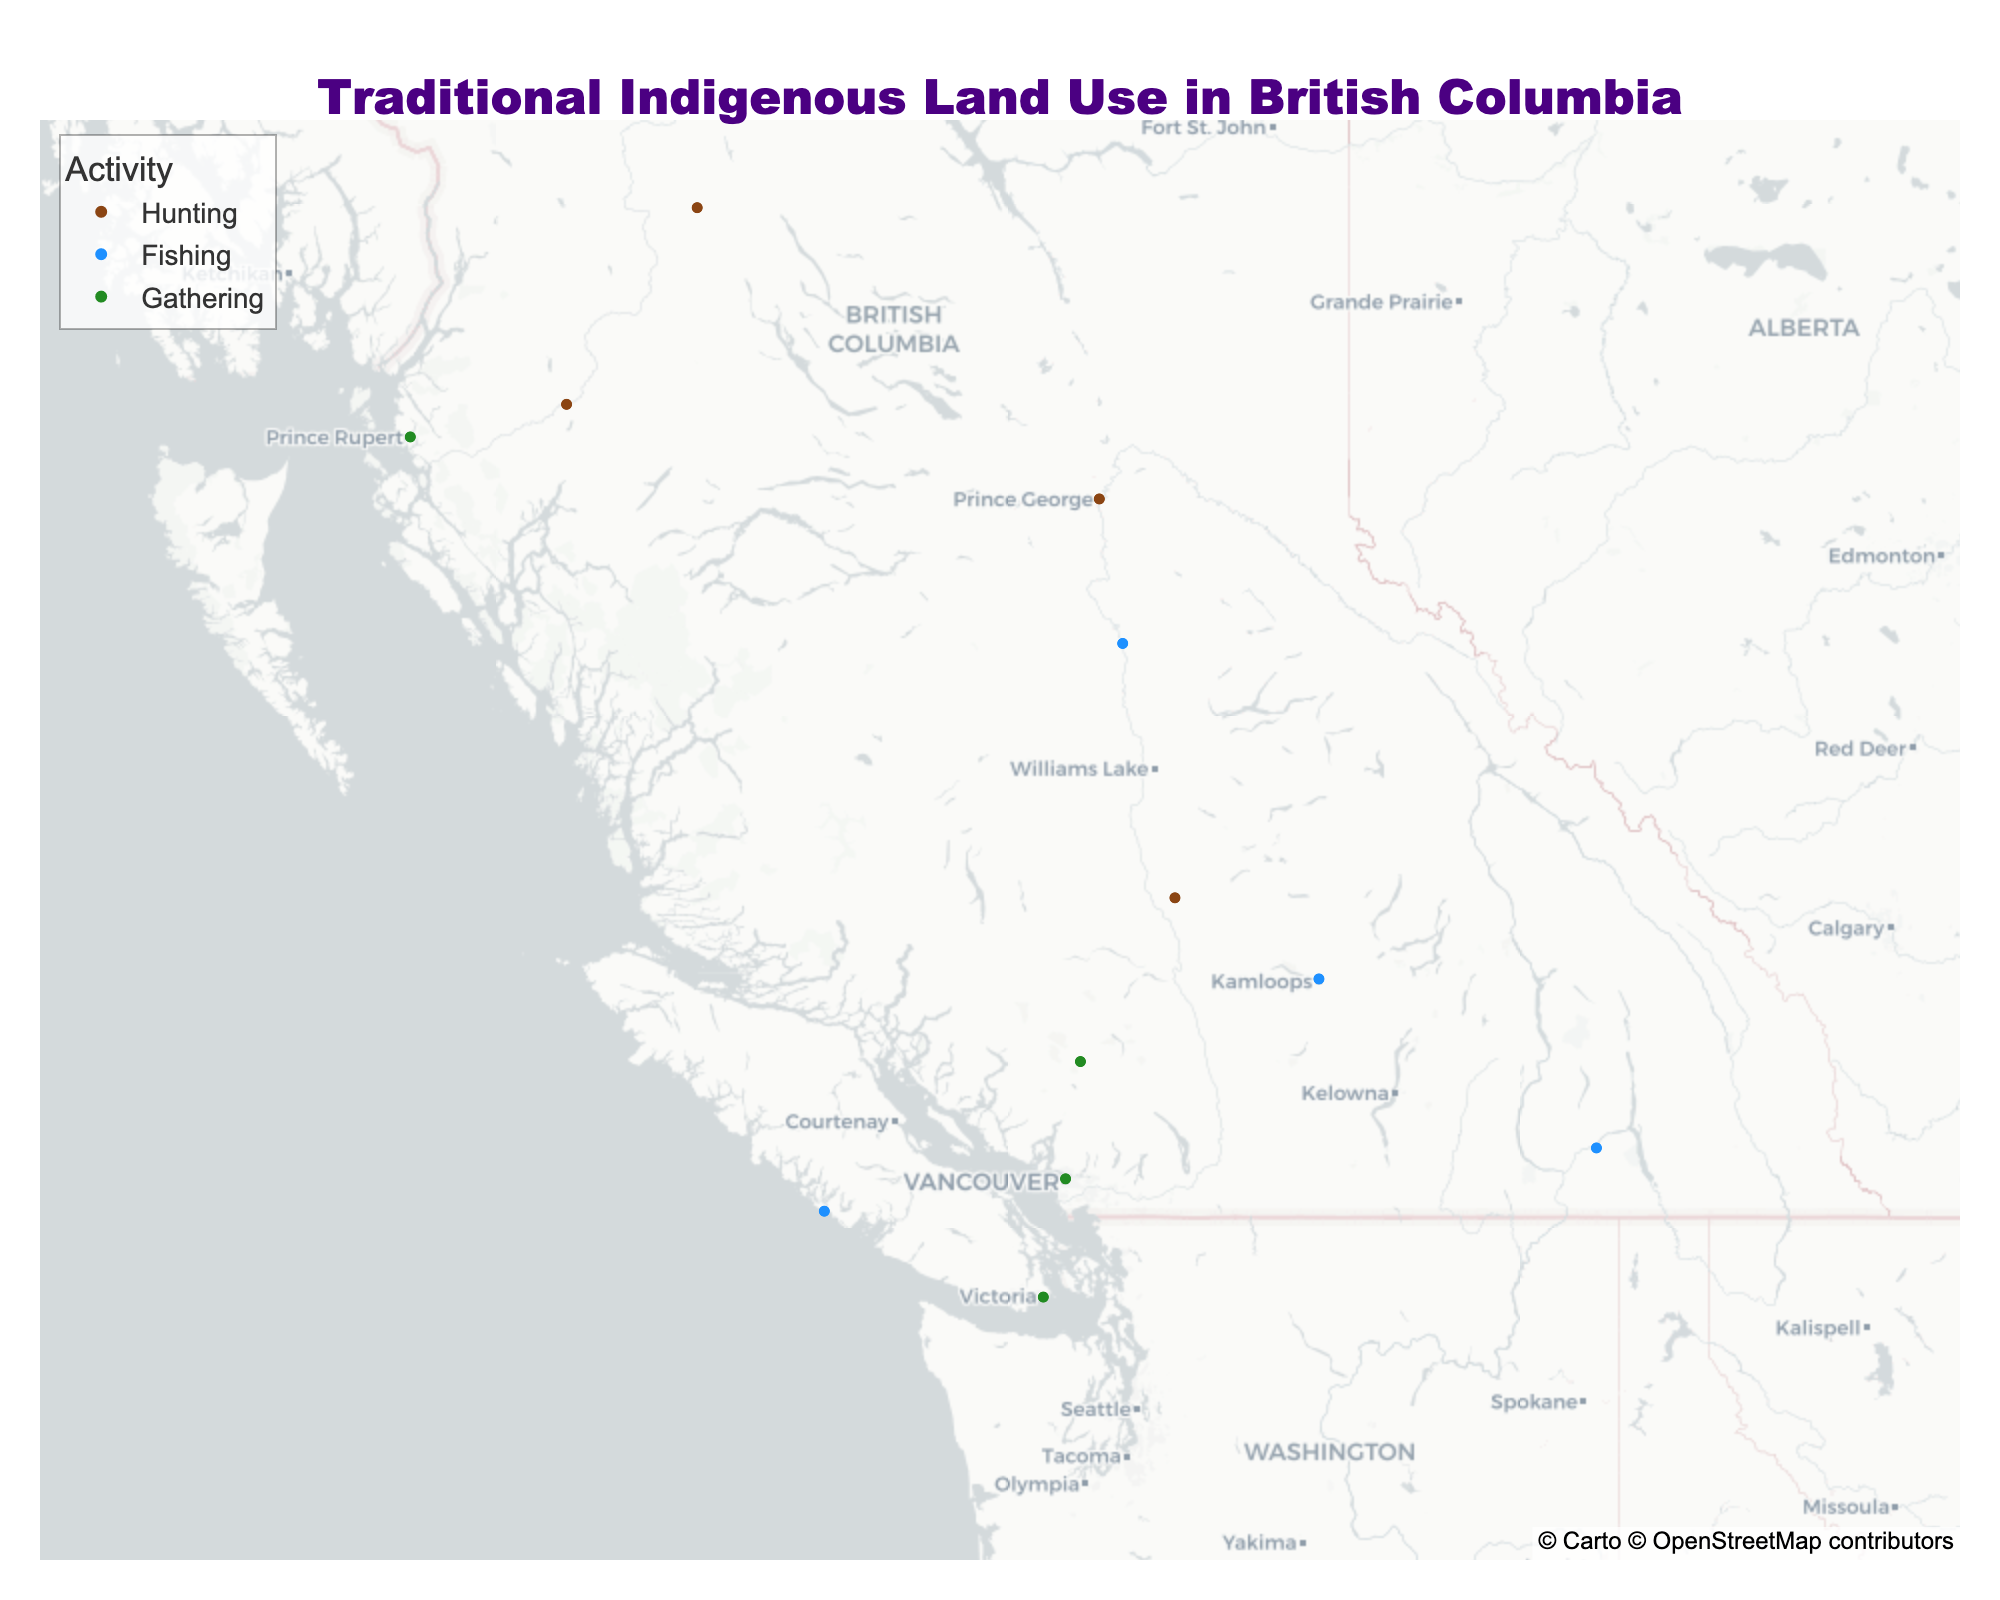What's the title of the figure? The title is typically prominently displayed at the top center of the plot. In this case, it's clearly written as "Traditional Indigenous Land Use in British Columbia".
Answer: Traditional Indigenous Land Use in British Columbia Which activity has the most data points on the map? By visually counting the data points associated with each color, we can determine that there are more points representing Hunting (brown-colored).
Answer: Hunting Which activity is represented by the color green? The color legend indicates that green is used to represent Gathering activities.
Answer: Gathering How many tribes are displayed on the map? By counting the unique tribe names displayed in the hover information for each data point, we find there are 12 tribes represented.
Answer: 12 Which tribe has data points in both Spring and Summer seasons? Hovering over each data point reveals details. We see that the Tsilhqot'in tribe, for example, does not repeat, but the Tsimshian tribe does, appearing in both Spring (Gathering) and Summer (Gathering).
Answer: Tsimshian Which tribe is associated with fishing in the Spring season? By examining the hover information for data points related to Fishing, we notice that the Ktunaxa tribe is associated with Fishing in the Spring.
Answer: Ktunaxa Which season has the most diverse activities displayed on the map? By categorizing the activities by season, we note that both Spring and Summer have all three activities (Hunting, Fishing, Gathering) represented.
Answer: Spring and Summer What is the northernmost point of Gathering activities according to the map? Observing the latitude values for Gathering activities, we find the northernmost Gathering activity is at 54.3169, -130.3201 (Tsimshian tribe).
Answer: 54.3169, -130.3201 Which activity occurs the most frequently in the Winter season? By examining the hover information for Winter data points, we see that Hunting has two instances while Fishing and Gathering do not appear. Hence, Hunting is more frequent in Winter.
Answer: Hunting Comparing Fall and Winter, which season has more Hunting areas represented on the map? By counting the Hunting data points for each season, we find Fall has two (Gitxsan and Secwepemc), and Winter also has two (Wet'suwet'en and Lheidli T'enneh). Therefore, both have an equal number of Hunting points.
Answer: Equal 